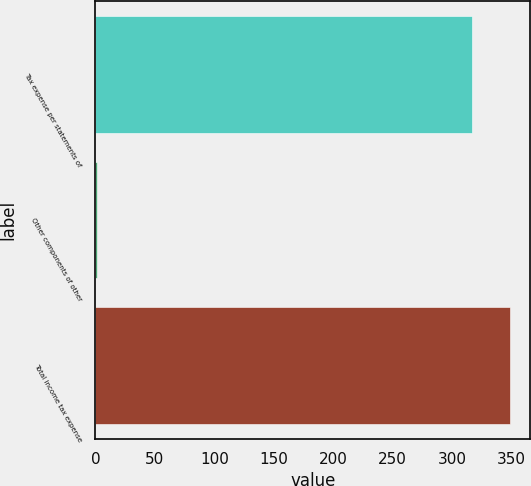<chart> <loc_0><loc_0><loc_500><loc_500><bar_chart><fcel>Tax expense per statements of<fcel>Other components of other<fcel>Total income tax expense<nl><fcel>317<fcel>1<fcel>348.6<nl></chart> 